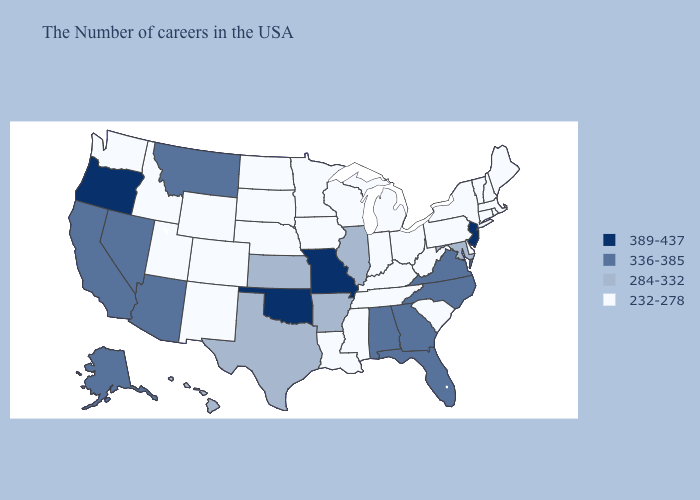What is the value of Wyoming?
Write a very short answer. 232-278. Does Maryland have a higher value than Colorado?
Write a very short answer. Yes. Among the states that border Louisiana , does Mississippi have the highest value?
Answer briefly. No. What is the highest value in the West ?
Answer briefly. 389-437. What is the lowest value in states that border Michigan?
Short answer required. 232-278. What is the value of Georgia?
Answer briefly. 336-385. Name the states that have a value in the range 336-385?
Write a very short answer. Virginia, North Carolina, Florida, Georgia, Alabama, Montana, Arizona, Nevada, California, Alaska. What is the lowest value in states that border North Dakota?
Be succinct. 232-278. Does Minnesota have the lowest value in the USA?
Be succinct. Yes. What is the highest value in the Northeast ?
Quick response, please. 389-437. Does the first symbol in the legend represent the smallest category?
Quick response, please. No. Among the states that border North Carolina , which have the lowest value?
Concise answer only. South Carolina, Tennessee. Does the map have missing data?
Give a very brief answer. No. Name the states that have a value in the range 336-385?
Give a very brief answer. Virginia, North Carolina, Florida, Georgia, Alabama, Montana, Arizona, Nevada, California, Alaska. What is the value of Virginia?
Be succinct. 336-385. 